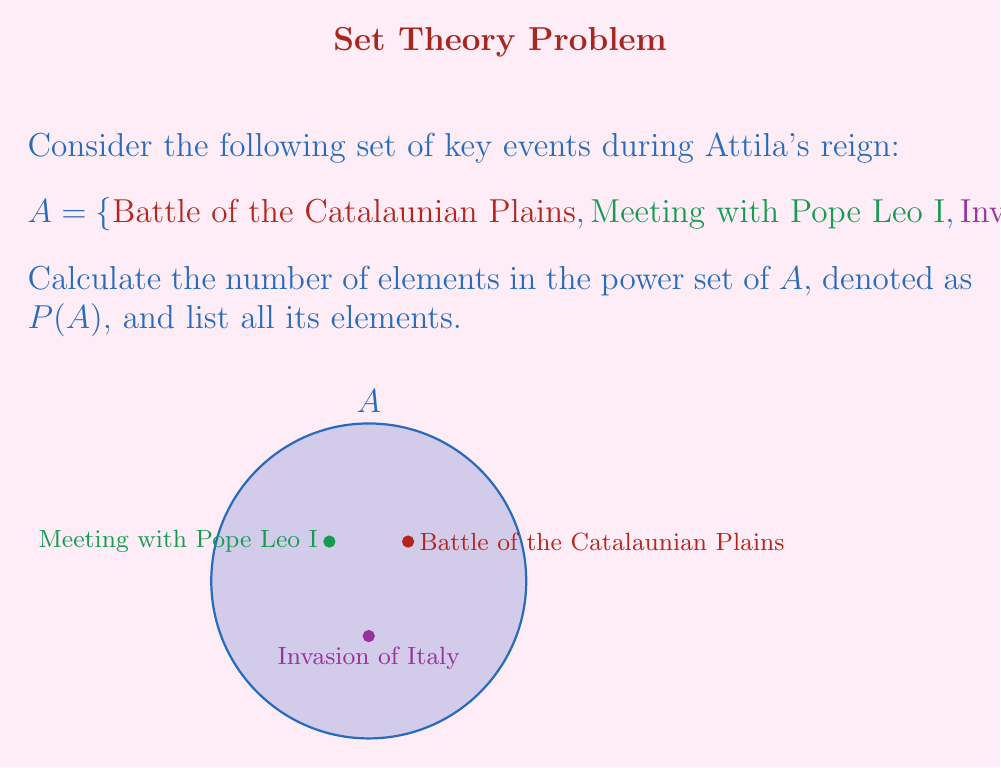What is the answer to this math problem? To solve this problem, let's follow these steps:

1) First, recall that for a set with $n$ elements, the number of elements in its power set is $2^n$.

2) In this case, set $A$ has 3 elements, so $n = 3$.

3) Therefore, the number of elements in $P(A)$ is $2^3 = 8$.

4) Now, let's list all the elements of $P(A)$:
   - The empty set: $\{\}$
   - Sets with one element: $\{\text{Battle of the Catalaunian Plains}\}$, $\{\text{Meeting with Pope Leo I}\}$, $\{\text{Invasion of Italy}\}$
   - Sets with two elements: $\{\text{Battle of the Catalaunian Plains, Meeting with Pope Leo I}\}$, $\{\text{Battle of the Catalaunian Plains, Invasion of Italy}\}$, $\{\text{Meeting with Pope Leo I, Invasion of Italy}\}$
   - The set with all three elements: $\{\text{Battle of the Catalaunian Plains, Meeting with Pope Leo I, Invasion of Italy}\}$

5) We can verify that we indeed have 8 elements in $P(A)$.

In set theory notation, we can write the power set as:

$$P(A) = \{\emptyset, \{a\}, \{b\}, \{c\}, \{a,b\}, \{a,c\}, \{b,c\}, \{a,b,c\}\}$$

where $a$, $b$, and $c$ represent the three events in set $A$.
Answer: $|P(A)| = 8$; $P(A) = \{\emptyset, \{a\}, \{b\}, \{c\}, \{a,b\}, \{a,c\}, \{b,c\}, \{a,b,c\}\}$ 